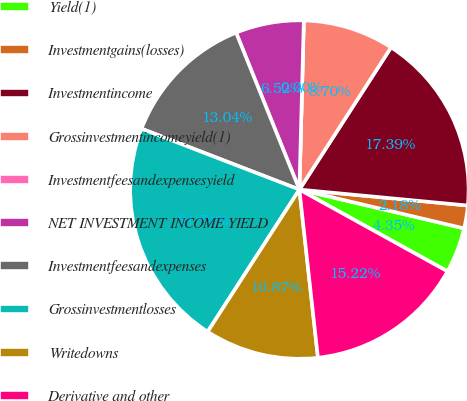<chart> <loc_0><loc_0><loc_500><loc_500><pie_chart><fcel>Yield(1)<fcel>Investmentgains(losses)<fcel>Investmentincome<fcel>Grossinvestmentincomeyield(1)<fcel>Investmentfeesandexpensesyield<fcel>NET INVESTMENT INCOME YIELD<fcel>Investmentfeesandexpenses<fcel>Grossinvestmentlosses<fcel>Writedowns<fcel>Derivative and other<nl><fcel>4.35%<fcel>2.18%<fcel>17.39%<fcel>8.7%<fcel>0.0%<fcel>6.52%<fcel>13.04%<fcel>21.74%<fcel>10.87%<fcel>15.22%<nl></chart> 